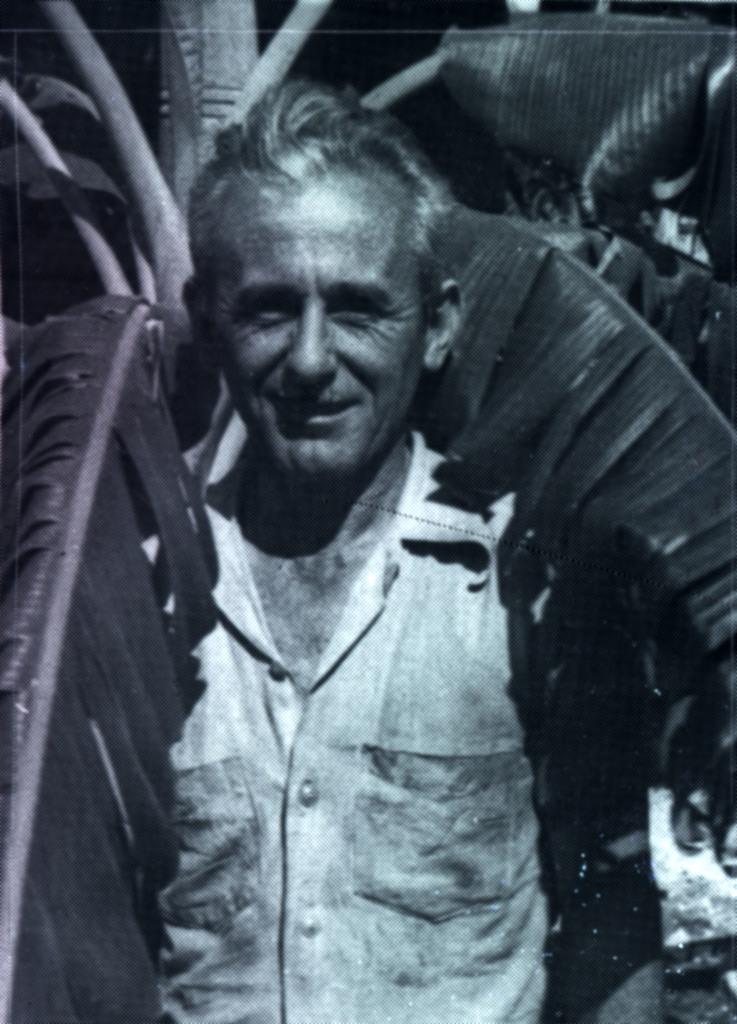What is the main subject of the image? There is a man standing in the image. What is the man's facial expression? The man is smiling. What type of plant can be seen in the image? There appears to be a tree with leaves in the image. How many cacti are visible in the image? There are no cacti present in the image; it features a tree with leaves. What type of group is shown interacting with the man in the image? There is no group present in the image; only the man and the tree with leaves are visible. 